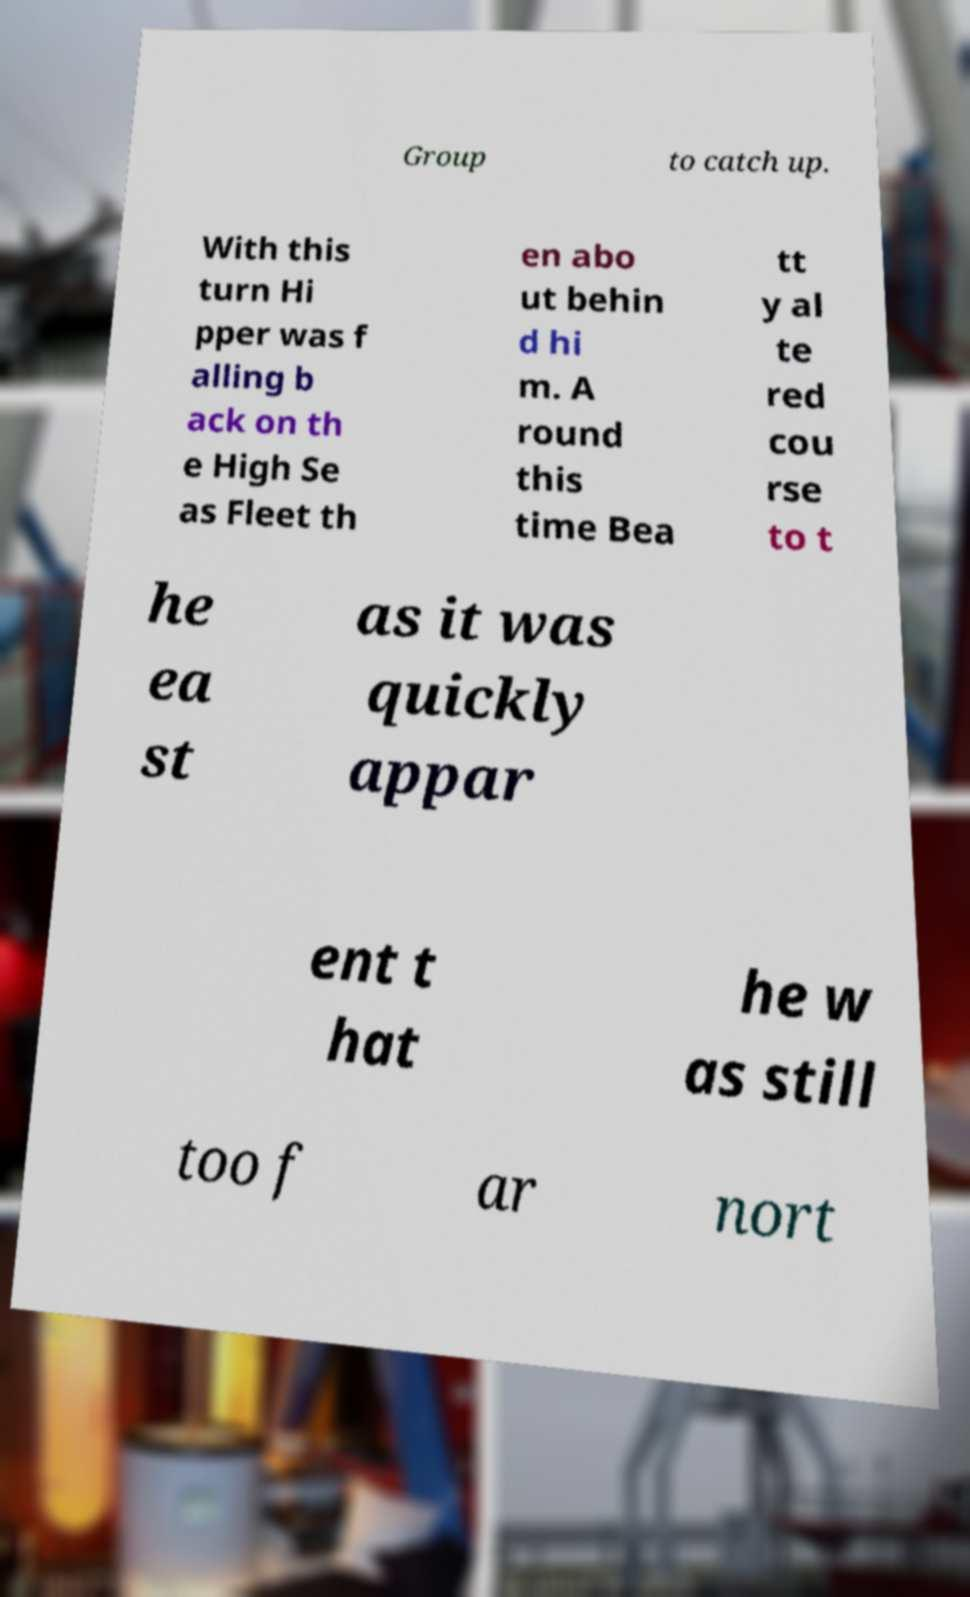For documentation purposes, I need the text within this image transcribed. Could you provide that? Group to catch up. With this turn Hi pper was f alling b ack on th e High Se as Fleet th en abo ut behin d hi m. A round this time Bea tt y al te red cou rse to t he ea st as it was quickly appar ent t hat he w as still too f ar nort 